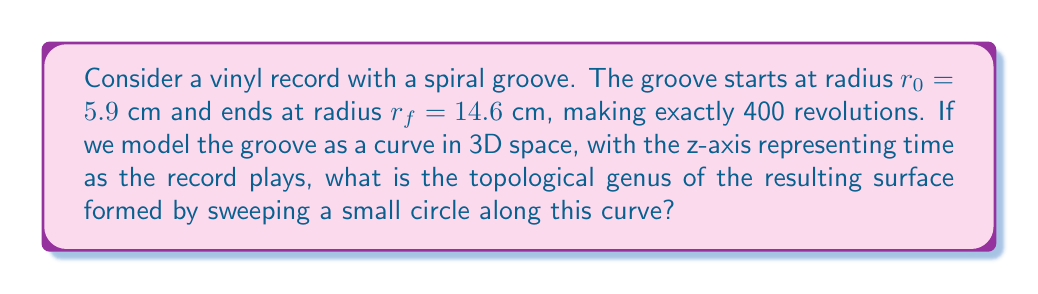Could you help me with this problem? To solve this problem, we need to consider the following steps:

1) First, let's visualize the spiral groove. In cylindrical coordinates $(r, \theta, z)$, the curve can be described as:

   $r = r_0 + k\theta$
   $z = c\theta$

   where $k$ is the radial increase per radian, and $c$ is a constant related to the playback speed.

2) The spiral makes 400 revolutions, so $\theta$ goes from 0 to $800\pi$.

3) We can calculate $k$:
   
   $k = \frac{r_f - r_0}{800\pi} = \frac{14.6 - 5.9}{800\pi} \approx 0.00344$ cm/radian

4) Now, imagine sweeping a small circle along this curve. This creates a surface that looks like a very long, thin torus wrapped around the center 400 times.

5) Topologically, this surface is equivalent to a torus, regardless of how many times it's wrapped around or how thin it is.

6) The genus of a surface is the number of "holes" it has. A torus has one hole, so its genus is 1.

7) The fact that the groove has a start and end point (it's not a closed loop) doesn't change the topology of the surface, as we're considering the surface formed by sweeping the circle along the entire curve.

Therefore, the topological genus of the surface is 1.
Answer: The topological genus of the surface formed by sweeping a small circle along the spiral groove is 1. 